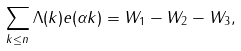Convert formula to latex. <formula><loc_0><loc_0><loc_500><loc_500>\sum _ { k \leq n } \Lambda ( k ) e ( \alpha k ) = W _ { 1 } - W _ { 2 } - W _ { 3 } ,</formula> 